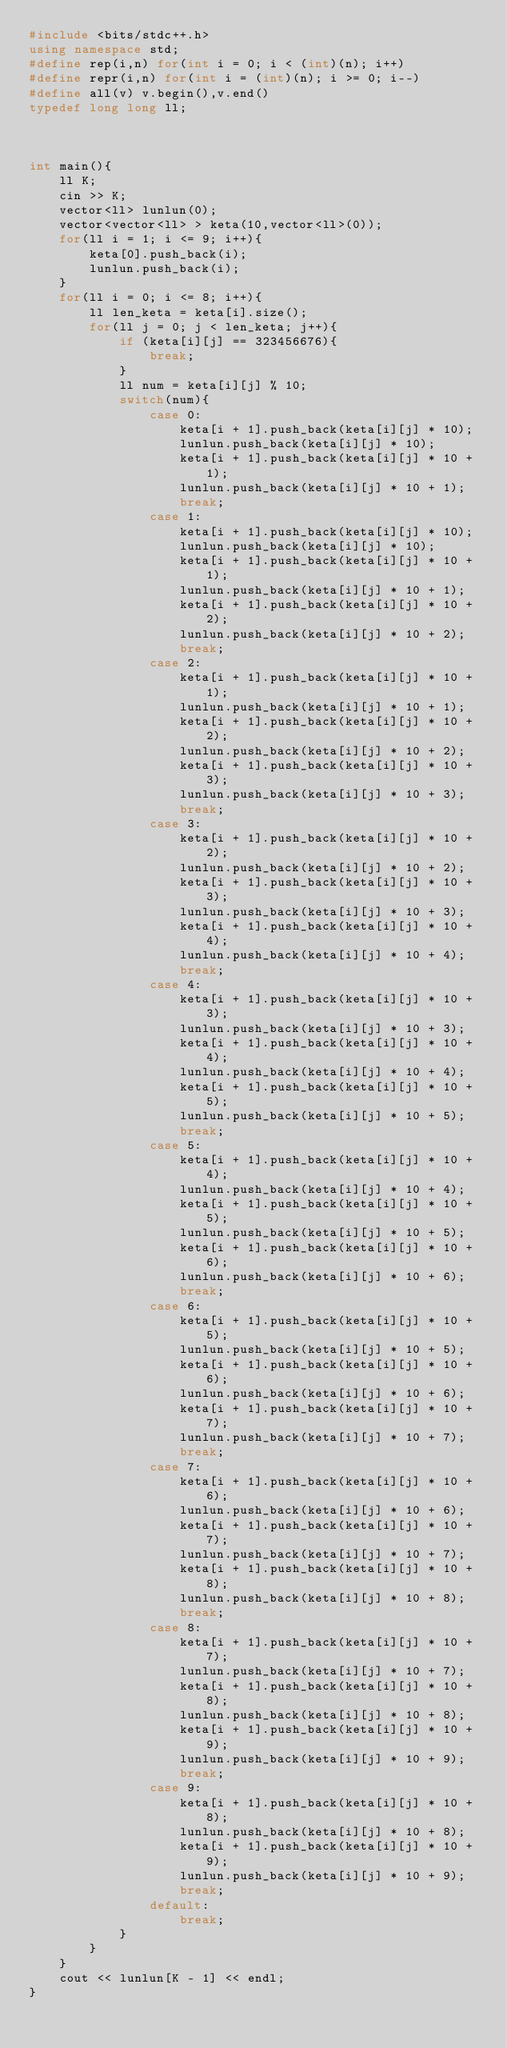Convert code to text. <code><loc_0><loc_0><loc_500><loc_500><_C++_>#include <bits/stdc++.h>
using namespace std;
#define rep(i,n) for(int i = 0; i < (int)(n); i++)
#define repr(i,n) for(int i = (int)(n); i >= 0; i--)
#define all(v) v.begin(),v.end()
typedef long long ll;



int main(){
    ll K;
    cin >> K;
    vector<ll> lunlun(0);
    vector<vector<ll> > keta(10,vector<ll>(0));
    for(ll i = 1; i <= 9; i++){
        keta[0].push_back(i);
        lunlun.push_back(i);
    }
    for(ll i = 0; i <= 8; i++){
        ll len_keta = keta[i].size();
        for(ll j = 0; j < len_keta; j++){
            if (keta[i][j] == 323456676){
                break;
            }
            ll num = keta[i][j] % 10;
            switch(num){
                case 0:
                    keta[i + 1].push_back(keta[i][j] * 10);
                    lunlun.push_back(keta[i][j] * 10);
                    keta[i + 1].push_back(keta[i][j] * 10 + 1);
                    lunlun.push_back(keta[i][j] * 10 + 1);
                    break;
                case 1:
                    keta[i + 1].push_back(keta[i][j] * 10);
                    lunlun.push_back(keta[i][j] * 10);
                    keta[i + 1].push_back(keta[i][j] * 10 + 1);
                    lunlun.push_back(keta[i][j] * 10 + 1);
                    keta[i + 1].push_back(keta[i][j] * 10 + 2);
                    lunlun.push_back(keta[i][j] * 10 + 2);
                    break;
                case 2:
                    keta[i + 1].push_back(keta[i][j] * 10 + 1);
                    lunlun.push_back(keta[i][j] * 10 + 1);
                    keta[i + 1].push_back(keta[i][j] * 10 + 2);
                    lunlun.push_back(keta[i][j] * 10 + 2);
                    keta[i + 1].push_back(keta[i][j] * 10 + 3);
                    lunlun.push_back(keta[i][j] * 10 + 3);
                    break;
                case 3:
                    keta[i + 1].push_back(keta[i][j] * 10 + 2);
                    lunlun.push_back(keta[i][j] * 10 + 2);
                    keta[i + 1].push_back(keta[i][j] * 10 + 3);
                    lunlun.push_back(keta[i][j] * 10 + 3);
                    keta[i + 1].push_back(keta[i][j] * 10 + 4);
                    lunlun.push_back(keta[i][j] * 10 + 4);
                    break;
                case 4:
                    keta[i + 1].push_back(keta[i][j] * 10 + 3);
                    lunlun.push_back(keta[i][j] * 10 + 3);
                    keta[i + 1].push_back(keta[i][j] * 10 + 4);
                    lunlun.push_back(keta[i][j] * 10 + 4);
                    keta[i + 1].push_back(keta[i][j] * 10 + 5);
                    lunlun.push_back(keta[i][j] * 10 + 5);
                    break;
                case 5:
                    keta[i + 1].push_back(keta[i][j] * 10 + 4);
                    lunlun.push_back(keta[i][j] * 10 + 4);
                    keta[i + 1].push_back(keta[i][j] * 10 + 5);
                    lunlun.push_back(keta[i][j] * 10 + 5);
                    keta[i + 1].push_back(keta[i][j] * 10 + 6);
                    lunlun.push_back(keta[i][j] * 10 + 6);
                    break;
                case 6:
                    keta[i + 1].push_back(keta[i][j] * 10 + 5);
                    lunlun.push_back(keta[i][j] * 10 + 5);
                    keta[i + 1].push_back(keta[i][j] * 10 + 6);
                    lunlun.push_back(keta[i][j] * 10 + 6);
                    keta[i + 1].push_back(keta[i][j] * 10 + 7);
                    lunlun.push_back(keta[i][j] * 10 + 7);
                    break;
                case 7:
                    keta[i + 1].push_back(keta[i][j] * 10 + 6);
                    lunlun.push_back(keta[i][j] * 10 + 6);
                    keta[i + 1].push_back(keta[i][j] * 10 + 7);
                    lunlun.push_back(keta[i][j] * 10 + 7);
                    keta[i + 1].push_back(keta[i][j] * 10 + 8);
                    lunlun.push_back(keta[i][j] * 10 + 8);
                    break;
                case 8:
                    keta[i + 1].push_back(keta[i][j] * 10 + 7);
                    lunlun.push_back(keta[i][j] * 10 + 7);
                    keta[i + 1].push_back(keta[i][j] * 10 + 8);
                    lunlun.push_back(keta[i][j] * 10 + 8);
                    keta[i + 1].push_back(keta[i][j] * 10 + 9);
                    lunlun.push_back(keta[i][j] * 10 + 9);
                    break;
                case 9:
                    keta[i + 1].push_back(keta[i][j] * 10 + 8);
                    lunlun.push_back(keta[i][j] * 10 + 8);
                    keta[i + 1].push_back(keta[i][j] * 10 + 9);
                    lunlun.push_back(keta[i][j] * 10 + 9);
                    break;
                default:
                    break;
            }
        }
    }
    cout << lunlun[K - 1] << endl;
}
</code> 